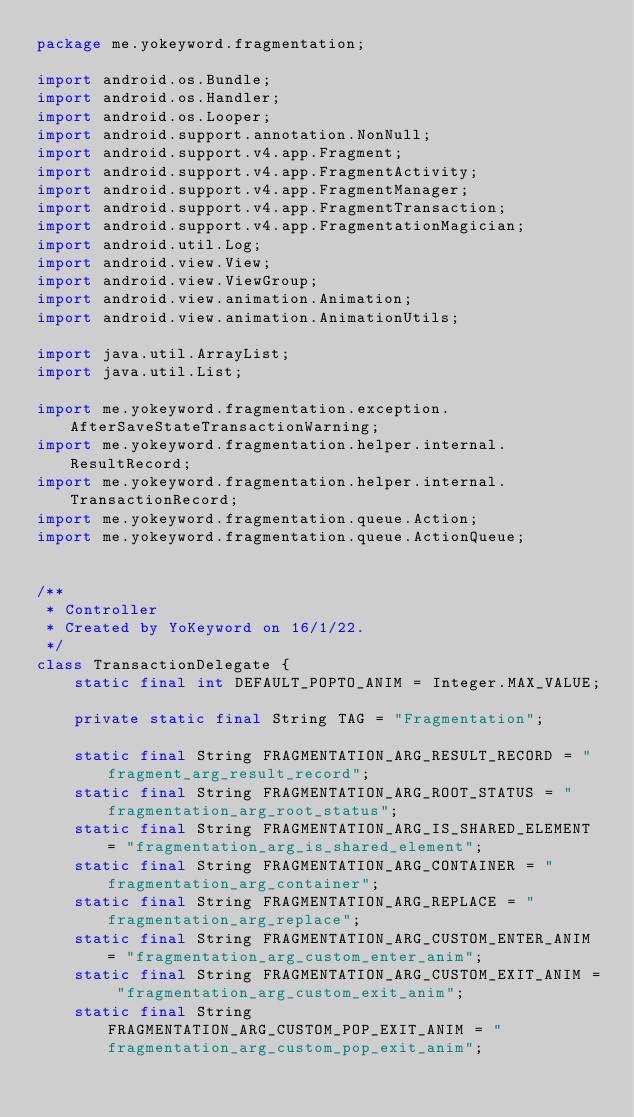Convert code to text. <code><loc_0><loc_0><loc_500><loc_500><_Java_>package me.yokeyword.fragmentation;

import android.os.Bundle;
import android.os.Handler;
import android.os.Looper;
import android.support.annotation.NonNull;
import android.support.v4.app.Fragment;
import android.support.v4.app.FragmentActivity;
import android.support.v4.app.FragmentManager;
import android.support.v4.app.FragmentTransaction;
import android.support.v4.app.FragmentationMagician;
import android.util.Log;
import android.view.View;
import android.view.ViewGroup;
import android.view.animation.Animation;
import android.view.animation.AnimationUtils;

import java.util.ArrayList;
import java.util.List;

import me.yokeyword.fragmentation.exception.AfterSaveStateTransactionWarning;
import me.yokeyword.fragmentation.helper.internal.ResultRecord;
import me.yokeyword.fragmentation.helper.internal.TransactionRecord;
import me.yokeyword.fragmentation.queue.Action;
import me.yokeyword.fragmentation.queue.ActionQueue;


/**
 * Controller
 * Created by YoKeyword on 16/1/22.
 */
class TransactionDelegate {
    static final int DEFAULT_POPTO_ANIM = Integer.MAX_VALUE;

    private static final String TAG = "Fragmentation";

    static final String FRAGMENTATION_ARG_RESULT_RECORD = "fragment_arg_result_record";
    static final String FRAGMENTATION_ARG_ROOT_STATUS = "fragmentation_arg_root_status";
    static final String FRAGMENTATION_ARG_IS_SHARED_ELEMENT = "fragmentation_arg_is_shared_element";
    static final String FRAGMENTATION_ARG_CONTAINER = "fragmentation_arg_container";
    static final String FRAGMENTATION_ARG_REPLACE = "fragmentation_arg_replace";
    static final String FRAGMENTATION_ARG_CUSTOM_ENTER_ANIM = "fragmentation_arg_custom_enter_anim";
    static final String FRAGMENTATION_ARG_CUSTOM_EXIT_ANIM = "fragmentation_arg_custom_exit_anim";
    static final String FRAGMENTATION_ARG_CUSTOM_POP_EXIT_ANIM = "fragmentation_arg_custom_pop_exit_anim";
</code> 